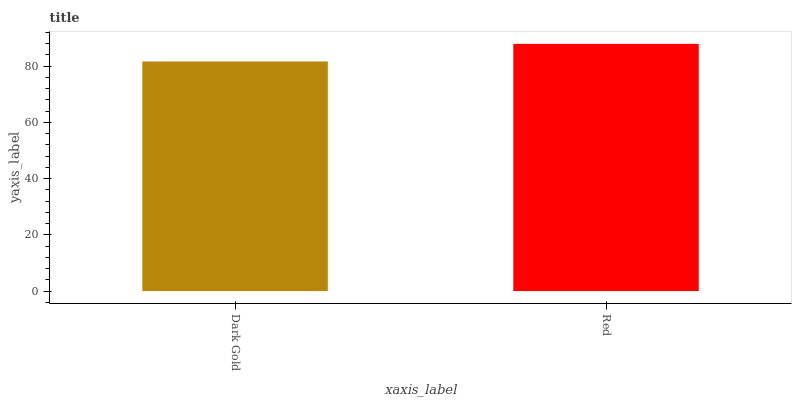Is Dark Gold the minimum?
Answer yes or no. Yes. Is Red the maximum?
Answer yes or no. Yes. Is Red the minimum?
Answer yes or no. No. Is Red greater than Dark Gold?
Answer yes or no. Yes. Is Dark Gold less than Red?
Answer yes or no. Yes. Is Dark Gold greater than Red?
Answer yes or no. No. Is Red less than Dark Gold?
Answer yes or no. No. Is Red the high median?
Answer yes or no. Yes. Is Dark Gold the low median?
Answer yes or no. Yes. Is Dark Gold the high median?
Answer yes or no. No. Is Red the low median?
Answer yes or no. No. 